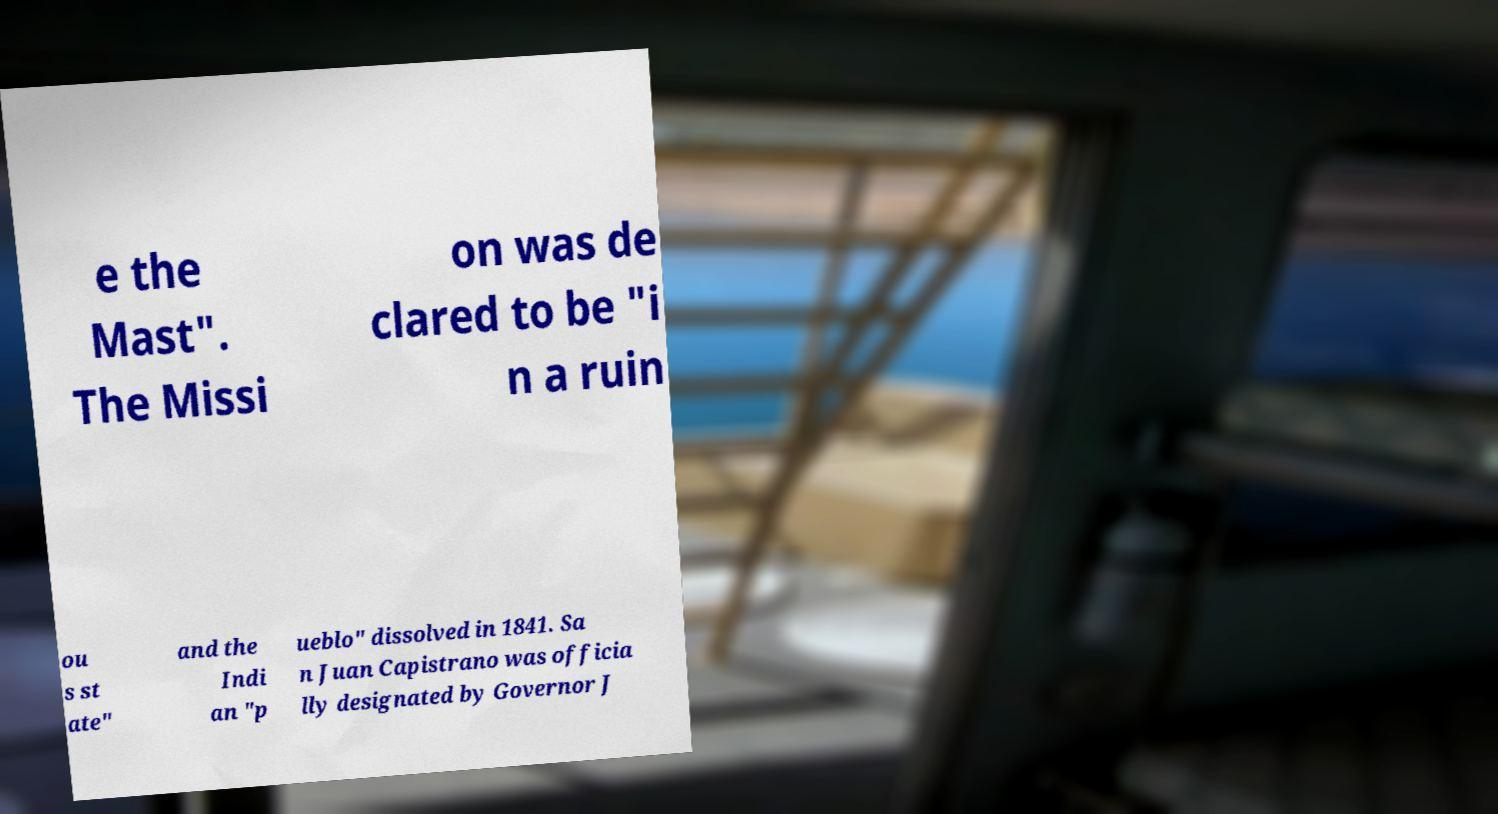Could you assist in decoding the text presented in this image and type it out clearly? e the Mast". The Missi on was de clared to be "i n a ruin ou s st ate" and the Indi an "p ueblo" dissolved in 1841. Sa n Juan Capistrano was officia lly designated by Governor J 